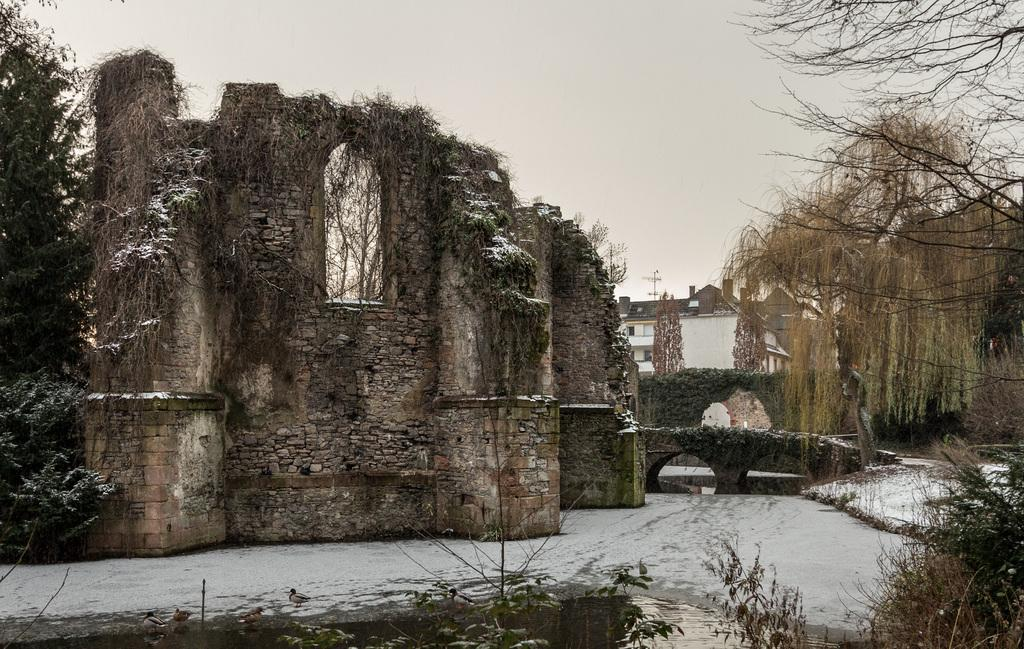What type of structures can be seen in the image? There are buildings in the image. What natural elements are present in the image? There are trees and a lake in the image. What type of vegetation can be seen in the image? There are plants in the image. What type of cup can be seen floating on the lake in the image? There is no cup present in the image; it only features buildings, trees, plants, and a lake. 